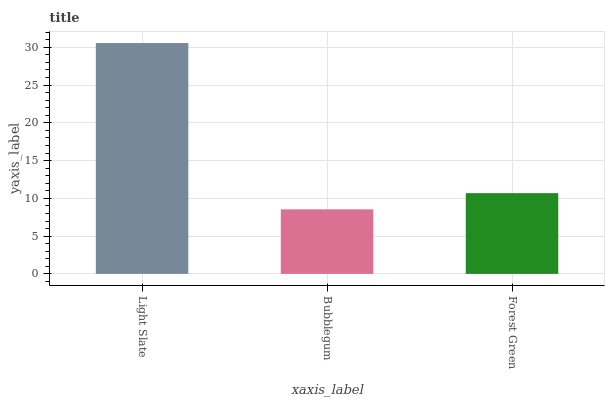Is Bubblegum the minimum?
Answer yes or no. Yes. Is Light Slate the maximum?
Answer yes or no. Yes. Is Forest Green the minimum?
Answer yes or no. No. Is Forest Green the maximum?
Answer yes or no. No. Is Forest Green greater than Bubblegum?
Answer yes or no. Yes. Is Bubblegum less than Forest Green?
Answer yes or no. Yes. Is Bubblegum greater than Forest Green?
Answer yes or no. No. Is Forest Green less than Bubblegum?
Answer yes or no. No. Is Forest Green the high median?
Answer yes or no. Yes. Is Forest Green the low median?
Answer yes or no. Yes. Is Light Slate the high median?
Answer yes or no. No. Is Light Slate the low median?
Answer yes or no. No. 